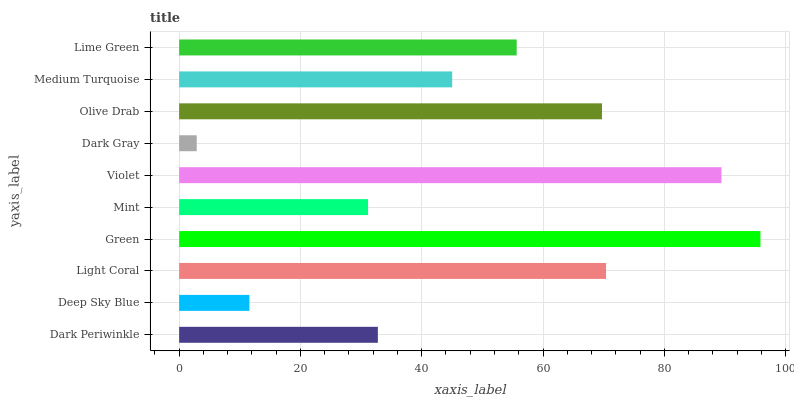Is Dark Gray the minimum?
Answer yes or no. Yes. Is Green the maximum?
Answer yes or no. Yes. Is Deep Sky Blue the minimum?
Answer yes or no. No. Is Deep Sky Blue the maximum?
Answer yes or no. No. Is Dark Periwinkle greater than Deep Sky Blue?
Answer yes or no. Yes. Is Deep Sky Blue less than Dark Periwinkle?
Answer yes or no. Yes. Is Deep Sky Blue greater than Dark Periwinkle?
Answer yes or no. No. Is Dark Periwinkle less than Deep Sky Blue?
Answer yes or no. No. Is Lime Green the high median?
Answer yes or no. Yes. Is Medium Turquoise the low median?
Answer yes or no. Yes. Is Green the high median?
Answer yes or no. No. Is Lime Green the low median?
Answer yes or no. No. 